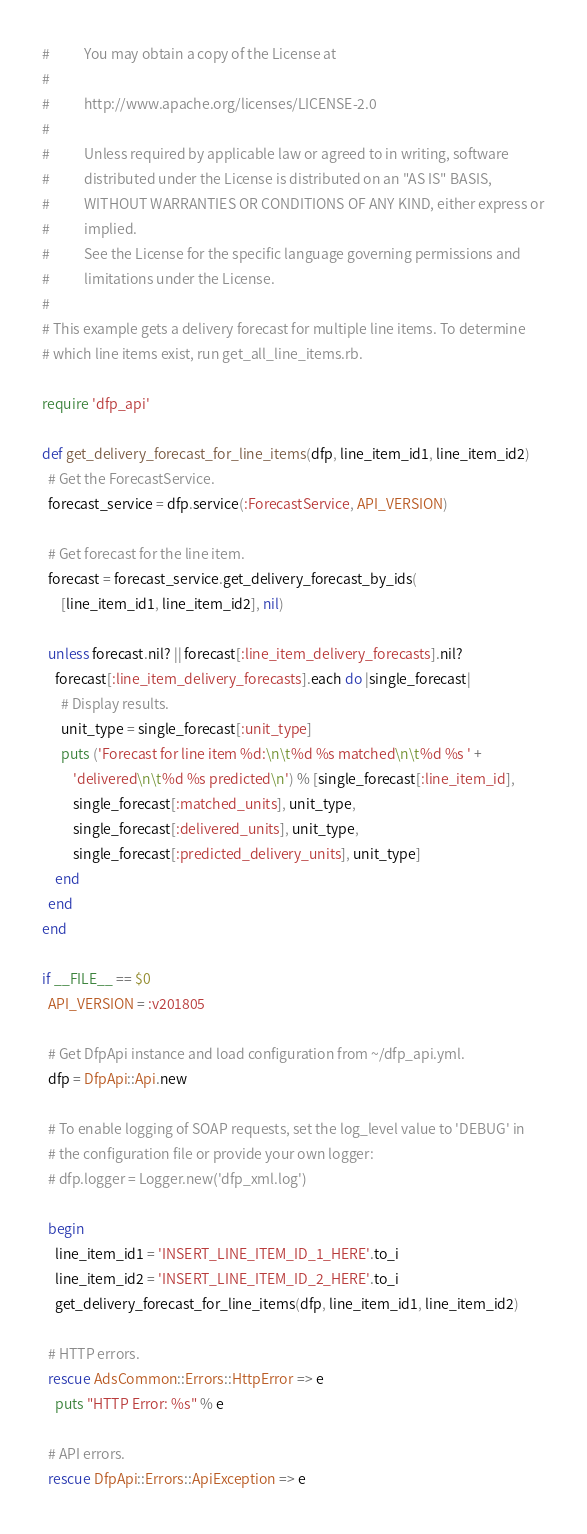Convert code to text. <code><loc_0><loc_0><loc_500><loc_500><_Ruby_>#           You may obtain a copy of the License at
#
#           http://www.apache.org/licenses/LICENSE-2.0
#
#           Unless required by applicable law or agreed to in writing, software
#           distributed under the License is distributed on an "AS IS" BASIS,
#           WITHOUT WARRANTIES OR CONDITIONS OF ANY KIND, either express or
#           implied.
#           See the License for the specific language governing permissions and
#           limitations under the License.
#
# This example gets a delivery forecast for multiple line items. To determine
# which line items exist, run get_all_line_items.rb.

require 'dfp_api'

def get_delivery_forecast_for_line_items(dfp, line_item_id1, line_item_id2)
  # Get the ForecastService.
  forecast_service = dfp.service(:ForecastService, API_VERSION)

  # Get forecast for the line item.
  forecast = forecast_service.get_delivery_forecast_by_ids(
      [line_item_id1, line_item_id2], nil)

  unless forecast.nil? || forecast[:line_item_delivery_forecasts].nil?
    forecast[:line_item_delivery_forecasts].each do |single_forecast|
      # Display results.
      unit_type = single_forecast[:unit_type]
      puts ('Forecast for line item %d:\n\t%d %s matched\n\t%d %s ' +
          'delivered\n\t%d %s predicted\n') % [single_forecast[:line_item_id],
          single_forecast[:matched_units], unit_type,
          single_forecast[:delivered_units], unit_type,
          single_forecast[:predicted_delivery_units], unit_type]
    end
  end
end

if __FILE__ == $0
  API_VERSION = :v201805

  # Get DfpApi instance and load configuration from ~/dfp_api.yml.
  dfp = DfpApi::Api.new

  # To enable logging of SOAP requests, set the log_level value to 'DEBUG' in
  # the configuration file or provide your own logger:
  # dfp.logger = Logger.new('dfp_xml.log')

  begin
    line_item_id1 = 'INSERT_LINE_ITEM_ID_1_HERE'.to_i
    line_item_id2 = 'INSERT_LINE_ITEM_ID_2_HERE'.to_i
    get_delivery_forecast_for_line_items(dfp, line_item_id1, line_item_id2)

  # HTTP errors.
  rescue AdsCommon::Errors::HttpError => e
    puts "HTTP Error: %s" % e

  # API errors.
  rescue DfpApi::Errors::ApiException => e</code> 